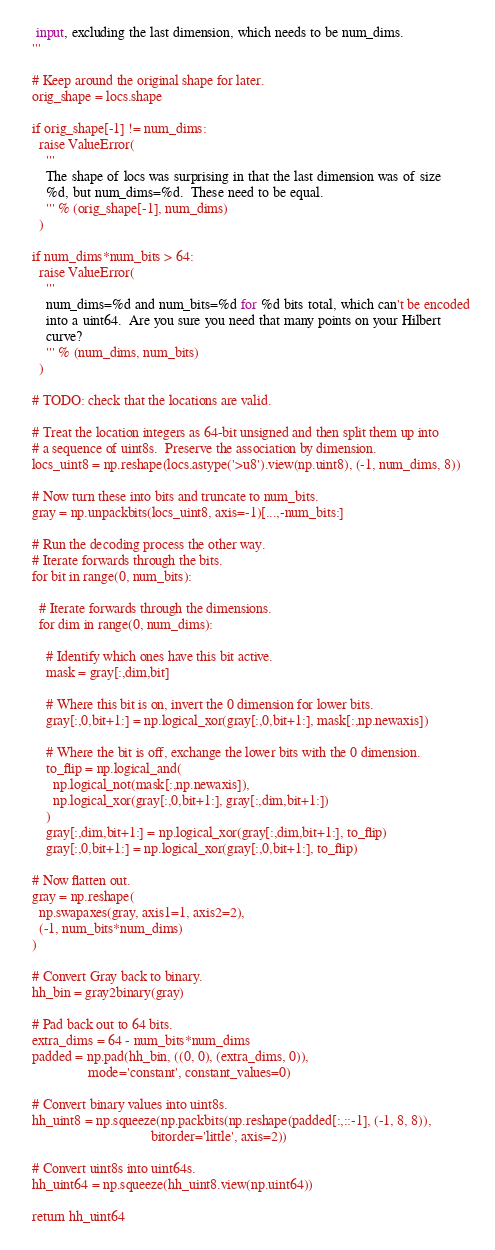Convert code to text. <code><loc_0><loc_0><loc_500><loc_500><_Python_>   input, excluding the last dimension, which needs to be num_dims.
  '''

  # Keep around the original shape for later.
  orig_shape = locs.shape

  if orig_shape[-1] != num_dims:
    raise ValueError(
      '''
      The shape of locs was surprising in that the last dimension was of size
      %d, but num_dims=%d.  These need to be equal.
      ''' % (orig_shape[-1], num_dims)
    )

  if num_dims*num_bits > 64:
    raise ValueError(
      '''
      num_dims=%d and num_bits=%d for %d bits total, which can't be encoded
      into a uint64.  Are you sure you need that many points on your Hilbert
      curve?
      ''' % (num_dims, num_bits)
    )

  # TODO: check that the locations are valid.

  # Treat the location integers as 64-bit unsigned and then split them up into
  # a sequence of uint8s.  Preserve the association by dimension.
  locs_uint8 = np.reshape(locs.astype('>u8').view(np.uint8), (-1, num_dims, 8))

  # Now turn these into bits and truncate to num_bits.
  gray = np.unpackbits(locs_uint8, axis=-1)[...,-num_bits:]

  # Run the decoding process the other way.
  # Iterate forwards through the bits.
  for bit in range(0, num_bits):

    # Iterate forwards through the dimensions.
    for dim in range(0, num_dims):

      # Identify which ones have this bit active.
      mask = gray[:,dim,bit]

      # Where this bit is on, invert the 0 dimension for lower bits.
      gray[:,0,bit+1:] = np.logical_xor(gray[:,0,bit+1:], mask[:,np.newaxis])

      # Where the bit is off, exchange the lower bits with the 0 dimension.
      to_flip = np.logical_and(
        np.logical_not(mask[:,np.newaxis]),
        np.logical_xor(gray[:,0,bit+1:], gray[:,dim,bit+1:])
      )
      gray[:,dim,bit+1:] = np.logical_xor(gray[:,dim,bit+1:], to_flip)
      gray[:,0,bit+1:] = np.logical_xor(gray[:,0,bit+1:], to_flip)

  # Now flatten out.
  gray = np.reshape(
    np.swapaxes(gray, axis1=1, axis2=2),
    (-1, num_bits*num_dims)
  )

  # Convert Gray back to binary.
  hh_bin = gray2binary(gray)

  # Pad back out to 64 bits.
  extra_dims = 64 - num_bits*num_dims
  padded = np.pad(hh_bin, ((0, 0), (extra_dims, 0)),
                  mode='constant', constant_values=0)

  # Convert binary values into uint8s.
  hh_uint8 = np.squeeze(np.packbits(np.reshape(padded[:,::-1], (-1, 8, 8)),
                                    bitorder='little', axis=2))

  # Convert uint8s into uint64s.
  hh_uint64 = np.squeeze(hh_uint8.view(np.uint64))

  return hh_uint64
</code> 